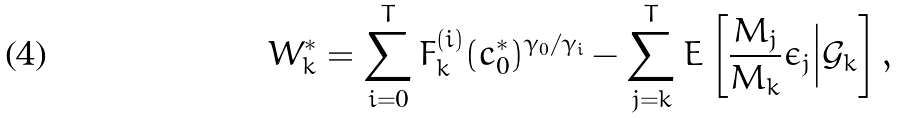<formula> <loc_0><loc_0><loc_500><loc_500>W ^ { * } _ { k } = \sum _ { i = 0 } ^ { T } F ^ { ( i ) } _ { k } ( c ^ { * } _ { 0 } ) ^ { \gamma _ { 0 } / \gamma _ { i } } - \sum _ { j = k } ^ { T } E \left [ \frac { M _ { j } } { M _ { k } } \epsilon _ { j } \Big | \mathcal { G } _ { k } \right ] ,</formula> 